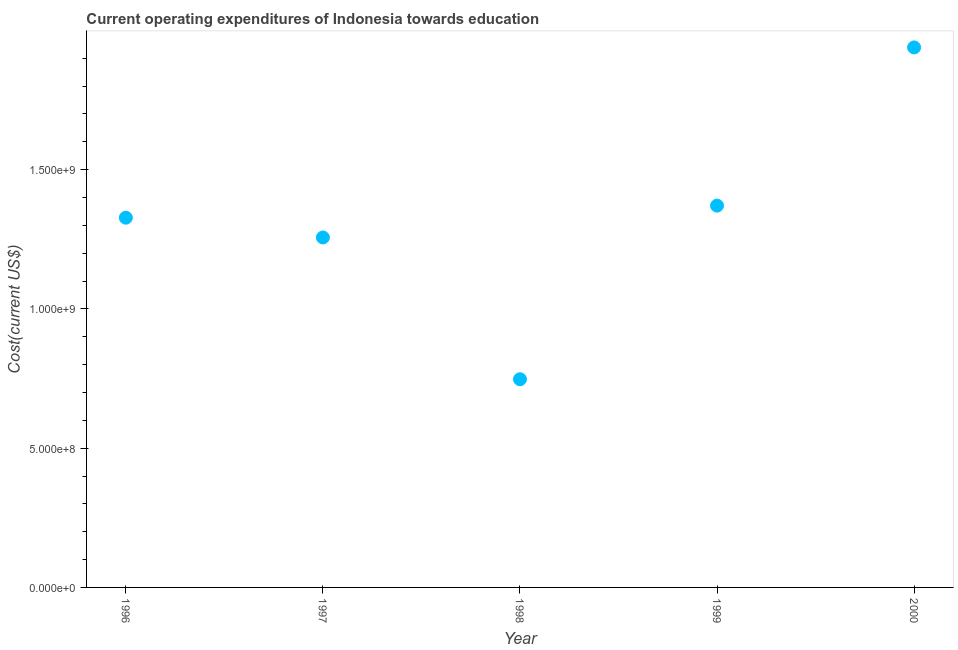What is the education expenditure in 1997?
Offer a very short reply. 1.26e+09. Across all years, what is the maximum education expenditure?
Provide a succinct answer. 1.94e+09. Across all years, what is the minimum education expenditure?
Make the answer very short. 7.48e+08. What is the sum of the education expenditure?
Your answer should be compact. 6.64e+09. What is the difference between the education expenditure in 1996 and 2000?
Ensure brevity in your answer.  -6.11e+08. What is the average education expenditure per year?
Offer a terse response. 1.33e+09. What is the median education expenditure?
Provide a succinct answer. 1.33e+09. In how many years, is the education expenditure greater than 1800000000 US$?
Ensure brevity in your answer.  1. Do a majority of the years between 1997 and 1996 (inclusive) have education expenditure greater than 800000000 US$?
Offer a very short reply. No. What is the ratio of the education expenditure in 1997 to that in 1999?
Make the answer very short. 0.92. Is the education expenditure in 1997 less than that in 2000?
Your answer should be very brief. Yes. Is the difference between the education expenditure in 1998 and 1999 greater than the difference between any two years?
Offer a terse response. No. What is the difference between the highest and the second highest education expenditure?
Your answer should be compact. 5.68e+08. What is the difference between the highest and the lowest education expenditure?
Offer a very short reply. 1.19e+09. In how many years, is the education expenditure greater than the average education expenditure taken over all years?
Your answer should be compact. 2. Does the graph contain grids?
Provide a succinct answer. No. What is the title of the graph?
Provide a short and direct response. Current operating expenditures of Indonesia towards education. What is the label or title of the Y-axis?
Your answer should be compact. Cost(current US$). What is the Cost(current US$) in 1996?
Provide a succinct answer. 1.33e+09. What is the Cost(current US$) in 1997?
Offer a terse response. 1.26e+09. What is the Cost(current US$) in 1998?
Make the answer very short. 7.48e+08. What is the Cost(current US$) in 1999?
Keep it short and to the point. 1.37e+09. What is the Cost(current US$) in 2000?
Offer a very short reply. 1.94e+09. What is the difference between the Cost(current US$) in 1996 and 1997?
Your answer should be very brief. 7.10e+07. What is the difference between the Cost(current US$) in 1996 and 1998?
Ensure brevity in your answer.  5.80e+08. What is the difference between the Cost(current US$) in 1996 and 1999?
Your response must be concise. -4.33e+07. What is the difference between the Cost(current US$) in 1996 and 2000?
Give a very brief answer. -6.11e+08. What is the difference between the Cost(current US$) in 1997 and 1998?
Give a very brief answer. 5.09e+08. What is the difference between the Cost(current US$) in 1997 and 1999?
Give a very brief answer. -1.14e+08. What is the difference between the Cost(current US$) in 1997 and 2000?
Your response must be concise. -6.82e+08. What is the difference between the Cost(current US$) in 1998 and 1999?
Keep it short and to the point. -6.23e+08. What is the difference between the Cost(current US$) in 1998 and 2000?
Keep it short and to the point. -1.19e+09. What is the difference between the Cost(current US$) in 1999 and 2000?
Your answer should be very brief. -5.68e+08. What is the ratio of the Cost(current US$) in 1996 to that in 1997?
Provide a short and direct response. 1.06. What is the ratio of the Cost(current US$) in 1996 to that in 1998?
Give a very brief answer. 1.78. What is the ratio of the Cost(current US$) in 1996 to that in 2000?
Your response must be concise. 0.69. What is the ratio of the Cost(current US$) in 1997 to that in 1998?
Keep it short and to the point. 1.68. What is the ratio of the Cost(current US$) in 1997 to that in 1999?
Keep it short and to the point. 0.92. What is the ratio of the Cost(current US$) in 1997 to that in 2000?
Ensure brevity in your answer.  0.65. What is the ratio of the Cost(current US$) in 1998 to that in 1999?
Give a very brief answer. 0.55. What is the ratio of the Cost(current US$) in 1998 to that in 2000?
Your response must be concise. 0.39. What is the ratio of the Cost(current US$) in 1999 to that in 2000?
Your response must be concise. 0.71. 